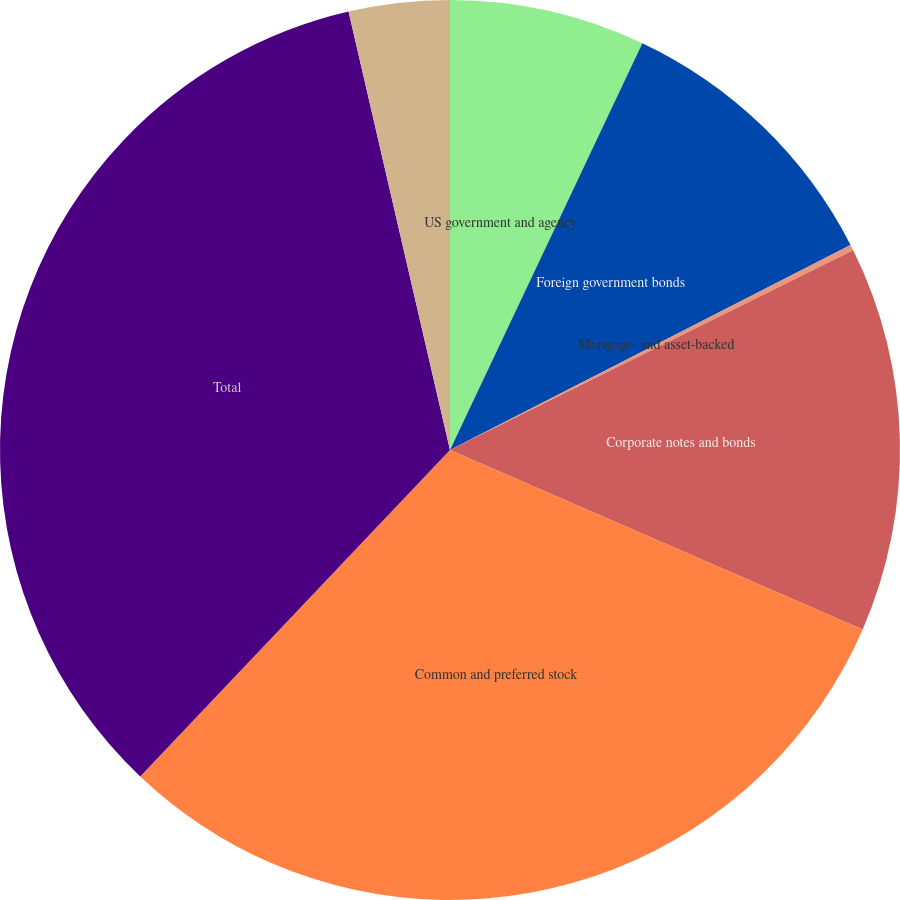<chart> <loc_0><loc_0><loc_500><loc_500><pie_chart><fcel>US government and agency<fcel>Foreign government bonds<fcel>Mortgage- and asset-backed<fcel>Corporate notes and bonds<fcel>Common and preferred stock<fcel>Total<fcel>Municipal securities<nl><fcel>7.03%<fcel>10.44%<fcel>0.21%<fcel>13.85%<fcel>30.56%<fcel>34.3%<fcel>3.62%<nl></chart> 